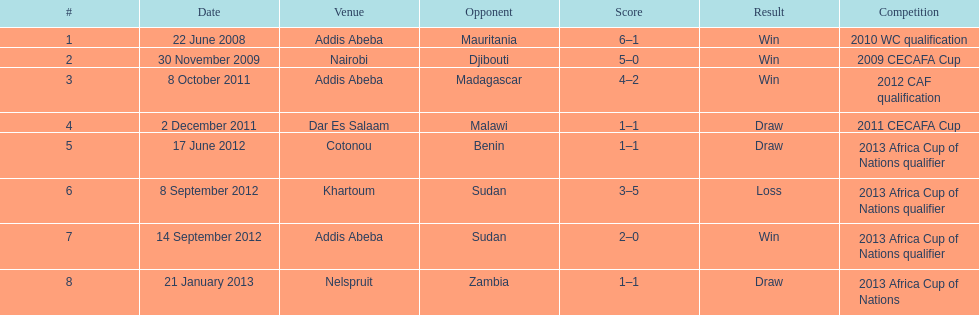How long in years down this table cover? 5. 